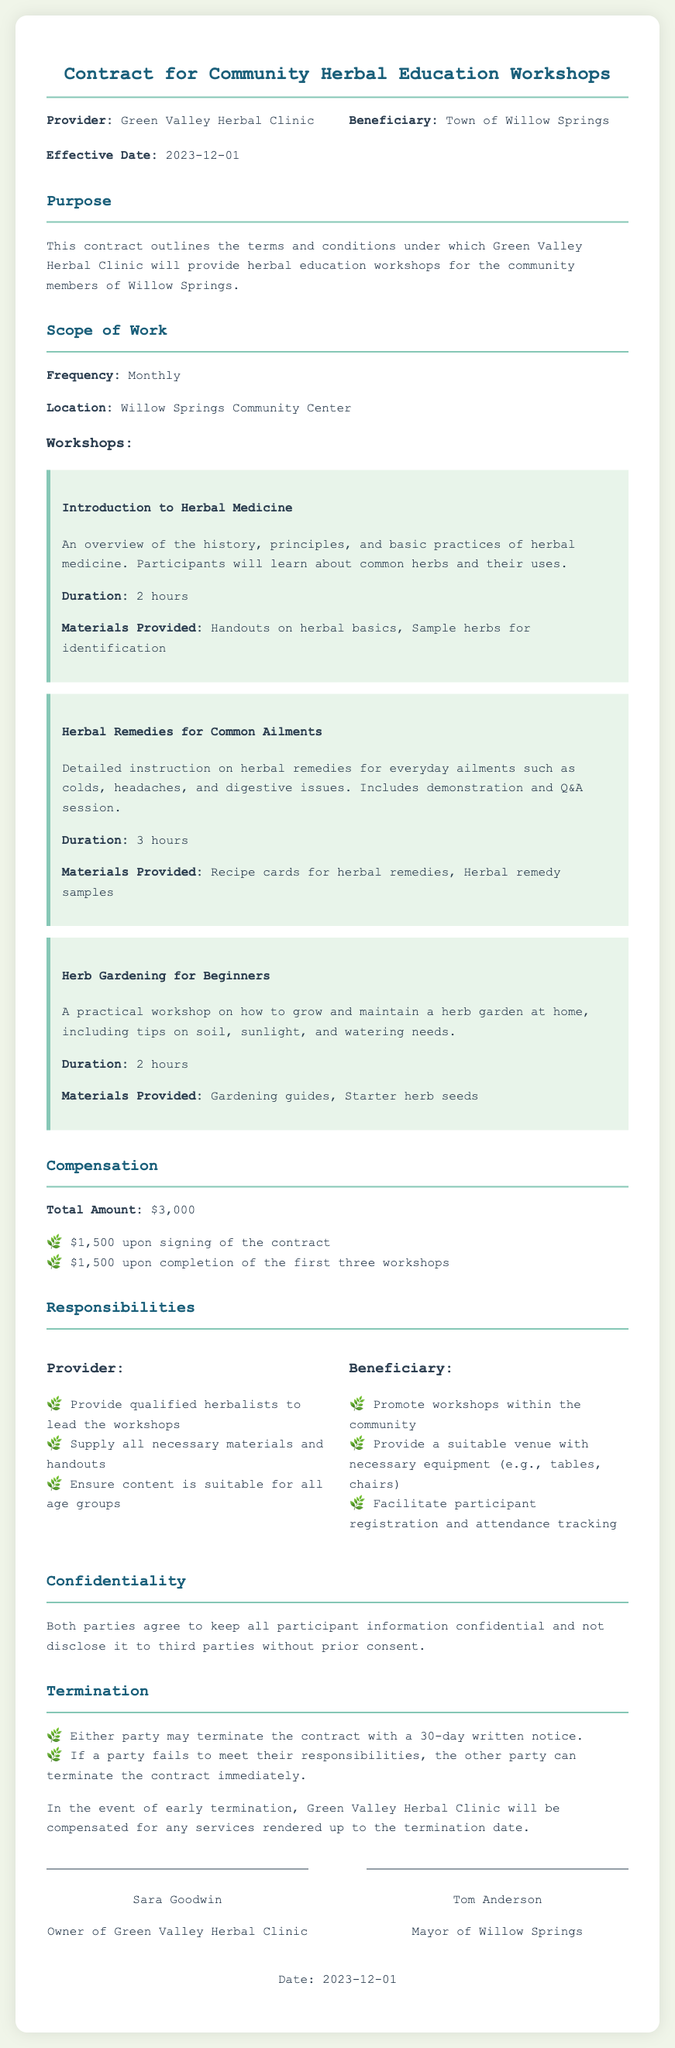What is the name of the provider? The provider named in the contract is Green Valley Herbal Clinic.
Answer: Green Valley Herbal Clinic What is the effective date of the contract? The effective date is explicitly stated in the document, which is December 1, 2023.
Answer: 2023-12-01 How many workshops are planned each month? The contract specifies that the workshops will be held monthly, indicating a frequency of one workshop per month.
Answer: Monthly What is the total compensation amount? The total amount of compensation stated in the contract is $3,000 for the provided services.
Answer: $3,000 What is one responsibility of the provider? One key responsibility of the provider is to supply all necessary materials and handouts for the workshops.
Answer: Supply all necessary materials and handouts What is the duration of the "Herbal Remedies for Common Ailments" workshop? The document mentions that this specific workshop has a duration of 3 hours.
Answer: 3 hours What is required from the beneficiary regarding venue? The beneficiary is responsible for providing a suitable venue with necessary equipment such as tables and chairs.
Answer: Provide a suitable venue with necessary equipment What happens if either party wants to terminate the contract? The document states that either party may terminate the contract with a 30-day written notice.
Answer: 30-day written notice Who is the mayor of Willow Springs? The contract lists Tom Anderson as the mayor of Willow Springs, indicating his role in the agreement.
Answer: Tom Anderson 